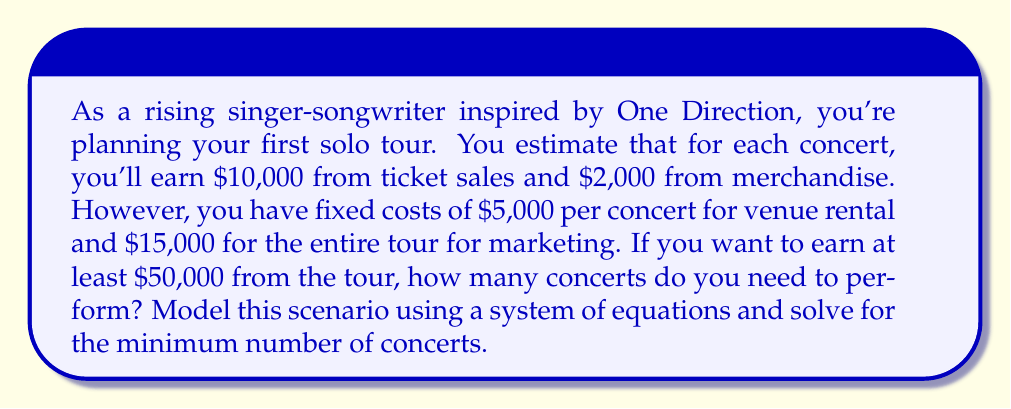Teach me how to tackle this problem. Let's approach this step-by-step:

1) Let $x$ be the number of concerts performed.

2) We can model the total revenue as:
   $R = 12000x$ (since each concert earns $10000 + $2000 = $12000)

3) We can model the total costs as:
   $C = 5000x + 15000$ (fixed cost per concert plus total marketing cost)

4) The profit (P) is the difference between revenue and costs:
   $P = R - C = 12000x - (5000x + 15000) = 7000x - 15000$

5) We want the profit to be at least $50,000, so we can set up the inequality:
   $7000x - 15000 \geq 50000$

6) Solving this inequality:
   $7000x \geq 65000$
   $x \geq \frac{65000}{7000} = 9.2857...$

7) Since we can't perform a fractional number of concerts, we need to round up to the nearest whole number.

Therefore, the minimum number of concerts needed is 10.

To verify:
Revenue from 10 concerts: $12000 * 10 = $120,000
Costs for 10 concerts: $(5000 * 10) + 15000 = $65,000
Profit: $120,000 - $65,000 = $55,000, which is indeed ≥ $50,000
Answer: 10 concerts 